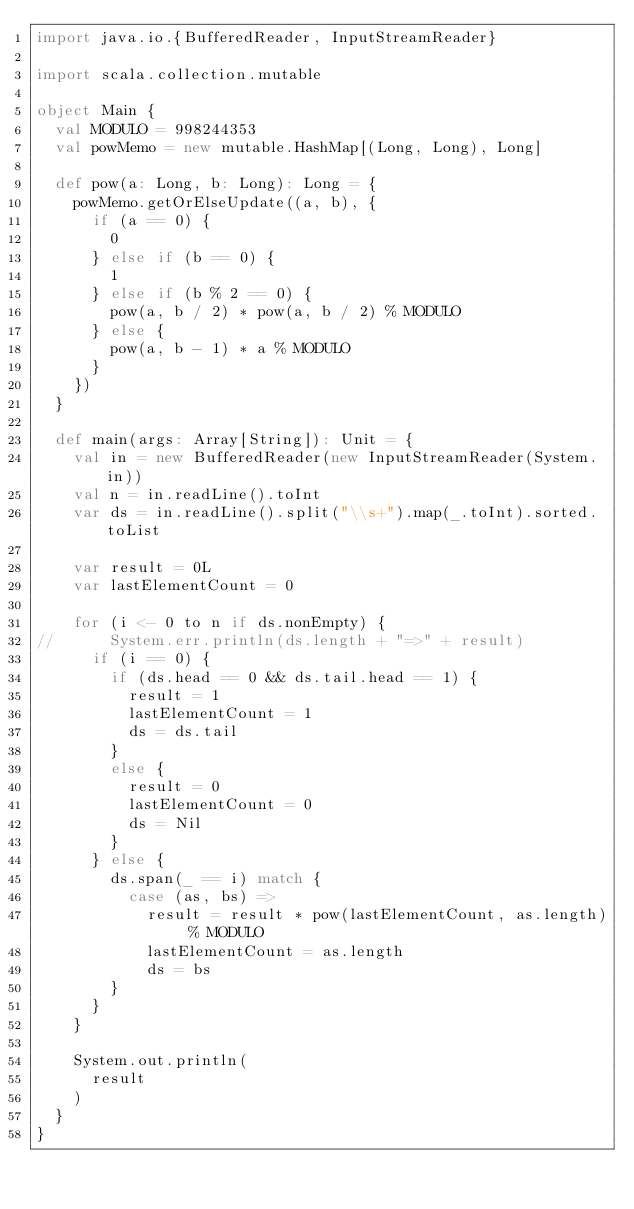Convert code to text. <code><loc_0><loc_0><loc_500><loc_500><_Scala_>import java.io.{BufferedReader, InputStreamReader}

import scala.collection.mutable

object Main {
  val MODULO = 998244353
  val powMemo = new mutable.HashMap[(Long, Long), Long]

  def pow(a: Long, b: Long): Long = {
    powMemo.getOrElseUpdate((a, b), {
      if (a == 0) {
        0
      } else if (b == 0) {
        1
      } else if (b % 2 == 0) {
        pow(a, b / 2) * pow(a, b / 2) % MODULO
      } else {
        pow(a, b - 1) * a % MODULO
      }
    })
  }

  def main(args: Array[String]): Unit = {
    val in = new BufferedReader(new InputStreamReader(System.in))
    val n = in.readLine().toInt
    var ds = in.readLine().split("\\s+").map(_.toInt).sorted.toList

    var result = 0L
    var lastElementCount = 0

    for (i <- 0 to n if ds.nonEmpty) {
//      System.err.println(ds.length + "=>" + result)
      if (i == 0) {
        if (ds.head == 0 && ds.tail.head == 1) {
          result = 1
          lastElementCount = 1
          ds = ds.tail
        }
        else {
          result = 0
          lastElementCount = 0
          ds = Nil
        }
      } else {
        ds.span(_ == i) match {
          case (as, bs) =>
            result = result * pow(lastElementCount, as.length) % MODULO
            lastElementCount = as.length
            ds = bs
        }
      }
    }

    System.out.println(
      result
    )
  }
}
</code> 